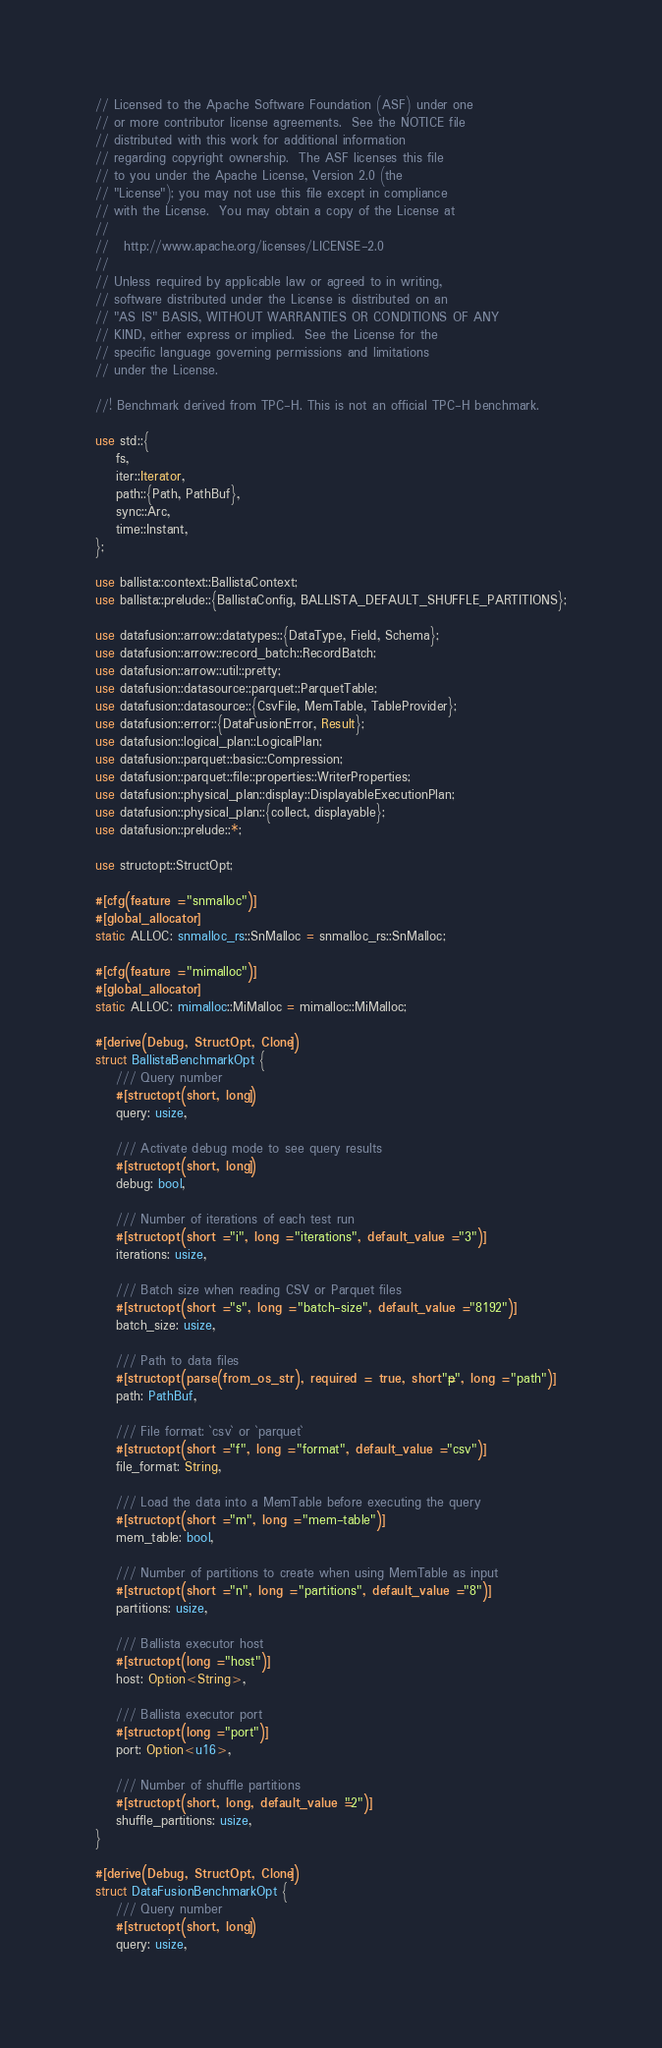<code> <loc_0><loc_0><loc_500><loc_500><_Rust_>// Licensed to the Apache Software Foundation (ASF) under one
// or more contributor license agreements.  See the NOTICE file
// distributed with this work for additional information
// regarding copyright ownership.  The ASF licenses this file
// to you under the Apache License, Version 2.0 (the
// "License"); you may not use this file except in compliance
// with the License.  You may obtain a copy of the License at
//
//   http://www.apache.org/licenses/LICENSE-2.0
//
// Unless required by applicable law or agreed to in writing,
// software distributed under the License is distributed on an
// "AS IS" BASIS, WITHOUT WARRANTIES OR CONDITIONS OF ANY
// KIND, either express or implied.  See the License for the
// specific language governing permissions and limitations
// under the License.

//! Benchmark derived from TPC-H. This is not an official TPC-H benchmark.

use std::{
    fs,
    iter::Iterator,
    path::{Path, PathBuf},
    sync::Arc,
    time::Instant,
};

use ballista::context::BallistaContext;
use ballista::prelude::{BallistaConfig, BALLISTA_DEFAULT_SHUFFLE_PARTITIONS};

use datafusion::arrow::datatypes::{DataType, Field, Schema};
use datafusion::arrow::record_batch::RecordBatch;
use datafusion::arrow::util::pretty;
use datafusion::datasource::parquet::ParquetTable;
use datafusion::datasource::{CsvFile, MemTable, TableProvider};
use datafusion::error::{DataFusionError, Result};
use datafusion::logical_plan::LogicalPlan;
use datafusion::parquet::basic::Compression;
use datafusion::parquet::file::properties::WriterProperties;
use datafusion::physical_plan::display::DisplayableExecutionPlan;
use datafusion::physical_plan::{collect, displayable};
use datafusion::prelude::*;

use structopt::StructOpt;

#[cfg(feature = "snmalloc")]
#[global_allocator]
static ALLOC: snmalloc_rs::SnMalloc = snmalloc_rs::SnMalloc;

#[cfg(feature = "mimalloc")]
#[global_allocator]
static ALLOC: mimalloc::MiMalloc = mimalloc::MiMalloc;

#[derive(Debug, StructOpt, Clone)]
struct BallistaBenchmarkOpt {
    /// Query number
    #[structopt(short, long)]
    query: usize,

    /// Activate debug mode to see query results
    #[structopt(short, long)]
    debug: bool,

    /// Number of iterations of each test run
    #[structopt(short = "i", long = "iterations", default_value = "3")]
    iterations: usize,

    /// Batch size when reading CSV or Parquet files
    #[structopt(short = "s", long = "batch-size", default_value = "8192")]
    batch_size: usize,

    /// Path to data files
    #[structopt(parse(from_os_str), required = true, short = "p", long = "path")]
    path: PathBuf,

    /// File format: `csv` or `parquet`
    #[structopt(short = "f", long = "format", default_value = "csv")]
    file_format: String,

    /// Load the data into a MemTable before executing the query
    #[structopt(short = "m", long = "mem-table")]
    mem_table: bool,

    /// Number of partitions to create when using MemTable as input
    #[structopt(short = "n", long = "partitions", default_value = "8")]
    partitions: usize,

    /// Ballista executor host
    #[structopt(long = "host")]
    host: Option<String>,

    /// Ballista executor port
    #[structopt(long = "port")]
    port: Option<u16>,

    /// Number of shuffle partitions
    #[structopt(short, long, default_value = "2")]
    shuffle_partitions: usize,
}

#[derive(Debug, StructOpt, Clone)]
struct DataFusionBenchmarkOpt {
    /// Query number
    #[structopt(short, long)]
    query: usize,
</code> 